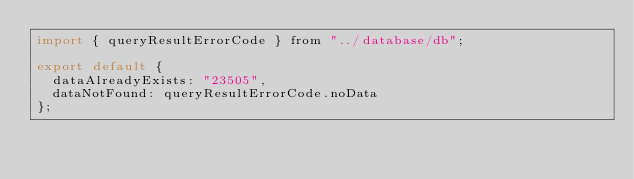Convert code to text. <code><loc_0><loc_0><loc_500><loc_500><_JavaScript_>import { queryResultErrorCode } from "../database/db";

export default {
  dataAlreadyExists: "23505",
  dataNotFound: queryResultErrorCode.noData
};
</code> 